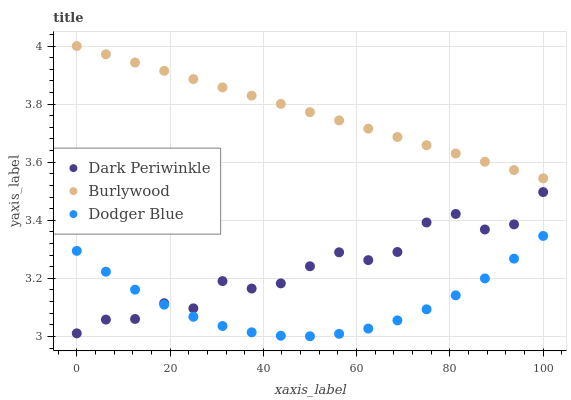Does Dodger Blue have the minimum area under the curve?
Answer yes or no. Yes. Does Burlywood have the maximum area under the curve?
Answer yes or no. Yes. Does Dark Periwinkle have the minimum area under the curve?
Answer yes or no. No. Does Dark Periwinkle have the maximum area under the curve?
Answer yes or no. No. Is Burlywood the smoothest?
Answer yes or no. Yes. Is Dark Periwinkle the roughest?
Answer yes or no. Yes. Is Dodger Blue the smoothest?
Answer yes or no. No. Is Dodger Blue the roughest?
Answer yes or no. No. Does Dodger Blue have the lowest value?
Answer yes or no. Yes. Does Dark Periwinkle have the lowest value?
Answer yes or no. No. Does Burlywood have the highest value?
Answer yes or no. Yes. Does Dark Periwinkle have the highest value?
Answer yes or no. No. Is Dodger Blue less than Burlywood?
Answer yes or no. Yes. Is Burlywood greater than Dodger Blue?
Answer yes or no. Yes. Does Dark Periwinkle intersect Dodger Blue?
Answer yes or no. Yes. Is Dark Periwinkle less than Dodger Blue?
Answer yes or no. No. Is Dark Periwinkle greater than Dodger Blue?
Answer yes or no. No. Does Dodger Blue intersect Burlywood?
Answer yes or no. No. 